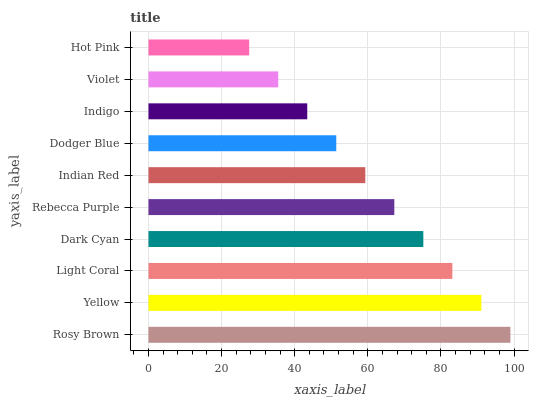Is Hot Pink the minimum?
Answer yes or no. Yes. Is Rosy Brown the maximum?
Answer yes or no. Yes. Is Yellow the minimum?
Answer yes or no. No. Is Yellow the maximum?
Answer yes or no. No. Is Rosy Brown greater than Yellow?
Answer yes or no. Yes. Is Yellow less than Rosy Brown?
Answer yes or no. Yes. Is Yellow greater than Rosy Brown?
Answer yes or no. No. Is Rosy Brown less than Yellow?
Answer yes or no. No. Is Rebecca Purple the high median?
Answer yes or no. Yes. Is Indian Red the low median?
Answer yes or no. Yes. Is Dark Cyan the high median?
Answer yes or no. No. Is Indigo the low median?
Answer yes or no. No. 